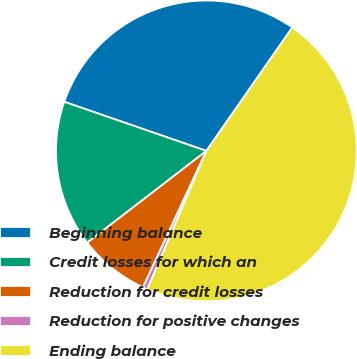Convert chart. <chart><loc_0><loc_0><loc_500><loc_500><pie_chart><fcel>Beginning balance<fcel>Credit losses for which an<fcel>Reduction for credit losses<fcel>Reduction for positive changes<fcel>Ending balance<nl><fcel>29.38%<fcel>15.74%<fcel>7.63%<fcel>0.5%<fcel>46.74%<nl></chart> 